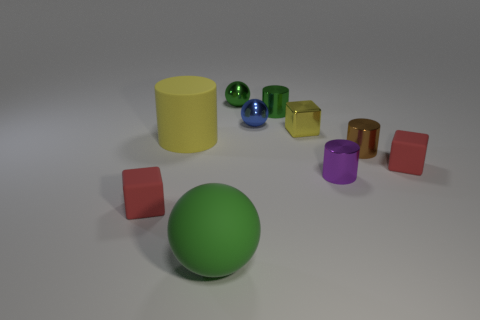There is a yellow shiny thing that is the same size as the blue ball; what shape is it?
Give a very brief answer. Cube. How many other things are there of the same material as the small blue object?
Your response must be concise. 5. There is a red thing that is left of the green rubber ball; how big is it?
Provide a succinct answer. Small. Does the small matte object to the right of the brown cylinder have the same shape as the brown object?
Offer a very short reply. No. There is a tiny green object that is the same shape as the large green object; what is it made of?
Your answer should be very brief. Metal. Are there any other things that are the same size as the yellow metal block?
Make the answer very short. Yes. Are any small green metallic cylinders visible?
Your answer should be compact. Yes. What is the material of the thing that is in front of the cube that is on the left side of the large thing that is behind the tiny purple cylinder?
Your answer should be compact. Rubber. There is a purple metallic object; does it have the same shape as the large thing left of the green rubber thing?
Provide a succinct answer. Yes. How many big green things are the same shape as the large yellow object?
Make the answer very short. 0. 